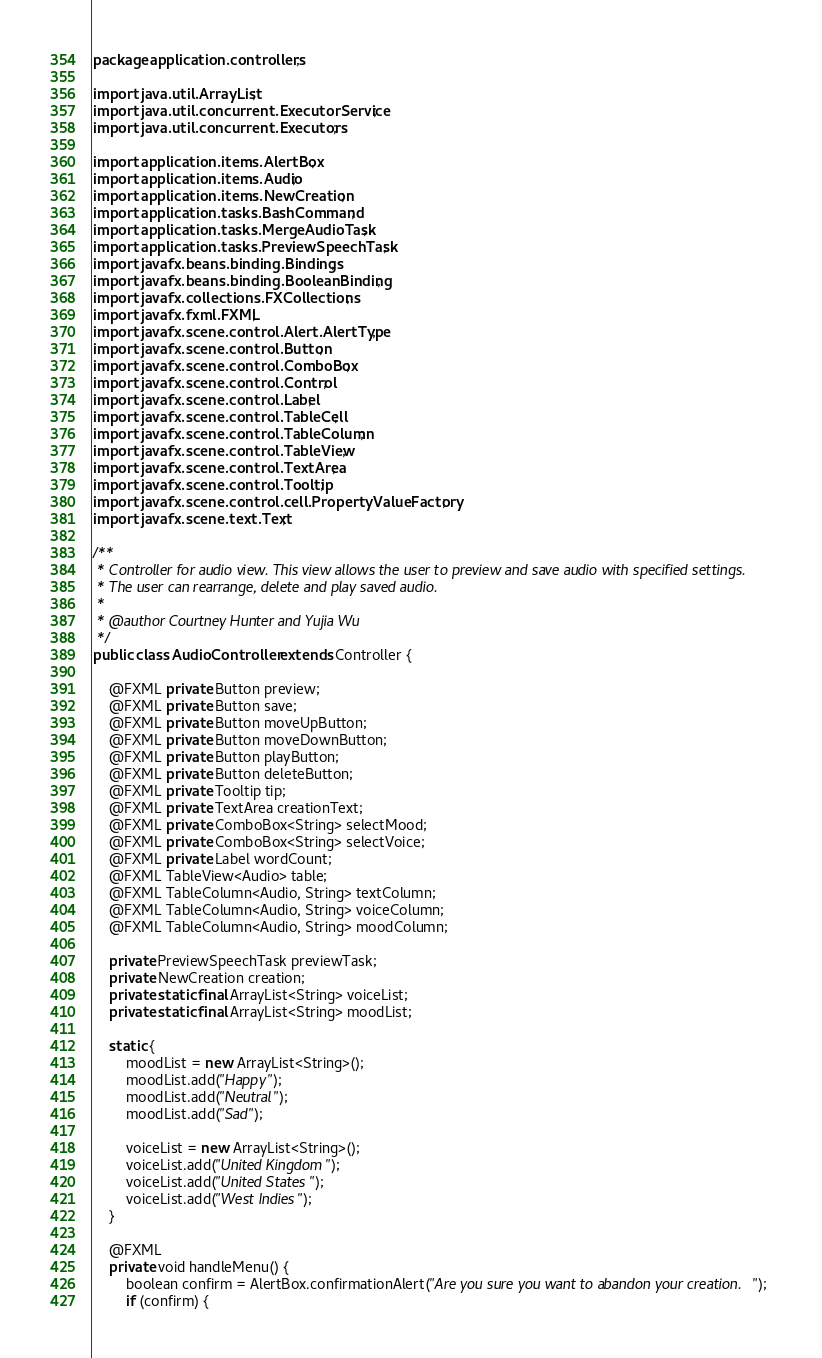<code> <loc_0><loc_0><loc_500><loc_500><_Java_>package application.controllers;

import java.util.ArrayList;
import java.util.concurrent.ExecutorService;
import java.util.concurrent.Executors;

import application.items.AlertBox;
import application.items.Audio;
import application.items.NewCreation;
import application.tasks.BashCommand;
import application.tasks.MergeAudioTask;
import application.tasks.PreviewSpeechTask;
import javafx.beans.binding.Bindings;
import javafx.beans.binding.BooleanBinding;
import javafx.collections.FXCollections;
import javafx.fxml.FXML;
import javafx.scene.control.Alert.AlertType;
import javafx.scene.control.Button;
import javafx.scene.control.ComboBox;
import javafx.scene.control.Control;
import javafx.scene.control.Label;
import javafx.scene.control.TableCell;
import javafx.scene.control.TableColumn;
import javafx.scene.control.TableView;
import javafx.scene.control.TextArea;
import javafx.scene.control.Tooltip;
import javafx.scene.control.cell.PropertyValueFactory;
import javafx.scene.text.Text;

/**
 * Controller for audio view. This view allows the user to preview and save audio with specified settings.
 * The user can rearrange, delete and play saved audio.
 * 
 * @author Courtney Hunter and Yujia Wu
 */
public class AudioController extends Controller {

	@FXML private Button preview;
	@FXML private Button save;
	@FXML private Button moveUpButton;
	@FXML private Button moveDownButton;
	@FXML private Button playButton;
	@FXML private Button deleteButton;
	@FXML private Tooltip tip;
	@FXML private TextArea creationText;
	@FXML private ComboBox<String> selectMood;
	@FXML private ComboBox<String> selectVoice;
	@FXML private Label wordCount;
	@FXML TableView<Audio> table;
	@FXML TableColumn<Audio, String> textColumn;
	@FXML TableColumn<Audio, String> voiceColumn;
	@FXML TableColumn<Audio, String> moodColumn;

	private PreviewSpeechTask previewTask;
	private NewCreation creation;
	private static final ArrayList<String> voiceList;
	private static final ArrayList<String> moodList;
	
	static {
		moodList = new ArrayList<String>();
		moodList.add("Happy");
		moodList.add("Neutral");
		moodList.add("Sad");

		voiceList = new ArrayList<String>();
		voiceList.add("United Kingdom");
		voiceList.add("United States");
		voiceList.add("West Indies");
	}

	@FXML
	private void handleMenu() {
		boolean confirm = AlertBox.confirmationAlert("Are you sure you want to abandon your creation.");
		if (confirm) {</code> 